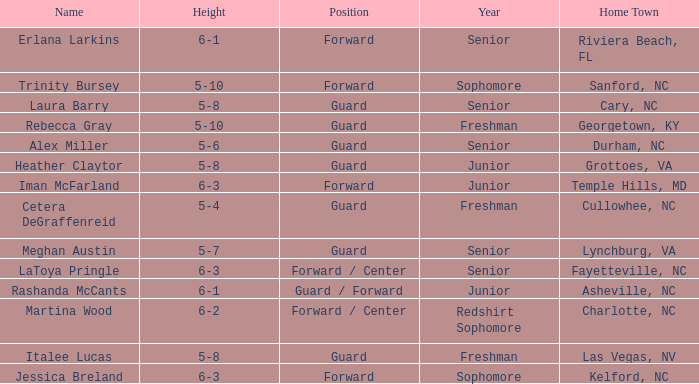What is the height of the player from Las Vegas, NV? 5-8. 